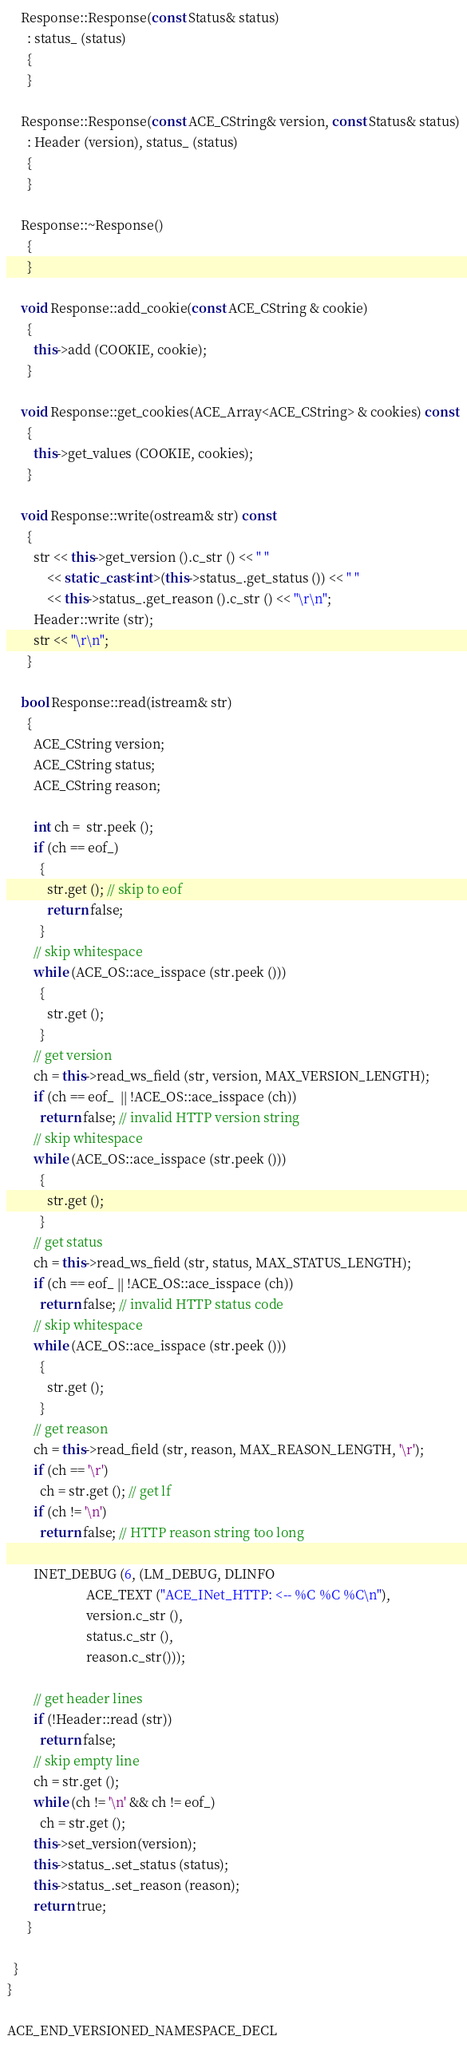<code> <loc_0><loc_0><loc_500><loc_500><_C++_>
    Response::Response(const Status& status)
      : status_ (status)
      {
      }

    Response::Response(const ACE_CString& version, const Status& status)
      : Header (version), status_ (status)
      {
      }

    Response::~Response()
      {
      }

    void Response::add_cookie(const ACE_CString & cookie)
      {
        this->add (COOKIE, cookie);
      }

    void Response::get_cookies(ACE_Array<ACE_CString> & cookies) const
      {
        this->get_values (COOKIE, cookies);
      }

    void Response::write(ostream& str) const
      {
        str << this->get_version ().c_str () << " "
            << static_cast<int>(this->status_.get_status ()) << " "
            << this->status_.get_reason ().c_str () << "\r\n";
        Header::write (str);
        str << "\r\n";
      }

    bool Response::read(istream& str)
      {
        ACE_CString version;
        ACE_CString status;
        ACE_CString reason;

        int ch =  str.peek ();
        if (ch == eof_)
          {
            str.get (); // skip to eof
            return false;
          }
        // skip whitespace
        while (ACE_OS::ace_isspace (str.peek ()))
          {
            str.get ();
          }
        // get version
        ch = this->read_ws_field (str, version, MAX_VERSION_LENGTH);
        if (ch == eof_  || !ACE_OS::ace_isspace (ch))
          return false; // invalid HTTP version string
        // skip whitespace
        while (ACE_OS::ace_isspace (str.peek ()))
          {
            str.get ();
          }
        // get status
        ch = this->read_ws_field (str, status, MAX_STATUS_LENGTH);
        if (ch == eof_ || !ACE_OS::ace_isspace (ch))
          return false; // invalid HTTP status code
        // skip whitespace
        while (ACE_OS::ace_isspace (str.peek ()))
          {
            str.get ();
          }
        // get reason
        ch = this->read_field (str, reason, MAX_REASON_LENGTH, '\r');
        if (ch == '\r')
          ch = str.get (); // get lf
        if (ch != '\n')
          return false; // HTTP reason string too long

        INET_DEBUG (6, (LM_DEBUG, DLINFO
                        ACE_TEXT ("ACE_INet_HTTP: <-- %C %C %C\n"),
                        version.c_str (),
                        status.c_str (),
                        reason.c_str()));

        // get header lines
        if (!Header::read (str))
          return false;
        // skip empty line
        ch = str.get ();
        while (ch != '\n' && ch != eof_)
          ch = str.get ();
        this->set_version(version);
        this->status_.set_status (status);
        this->status_.set_reason (reason);
        return true;
      }

  }
}

ACE_END_VERSIONED_NAMESPACE_DECL
</code> 